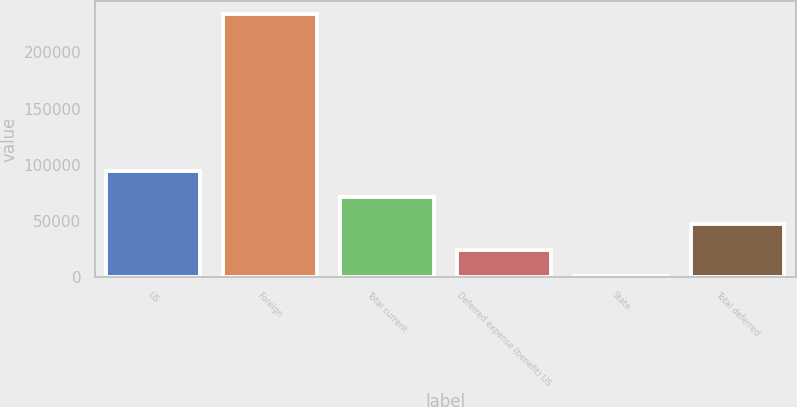<chart> <loc_0><loc_0><loc_500><loc_500><bar_chart><fcel>US<fcel>Foreign<fcel>Total current<fcel>Deferred expense (benefit) US<fcel>State<fcel>Total deferred<nl><fcel>94402.6<fcel>234340<fcel>71079.7<fcel>24433.9<fcel>1111<fcel>47756.8<nl></chart> 